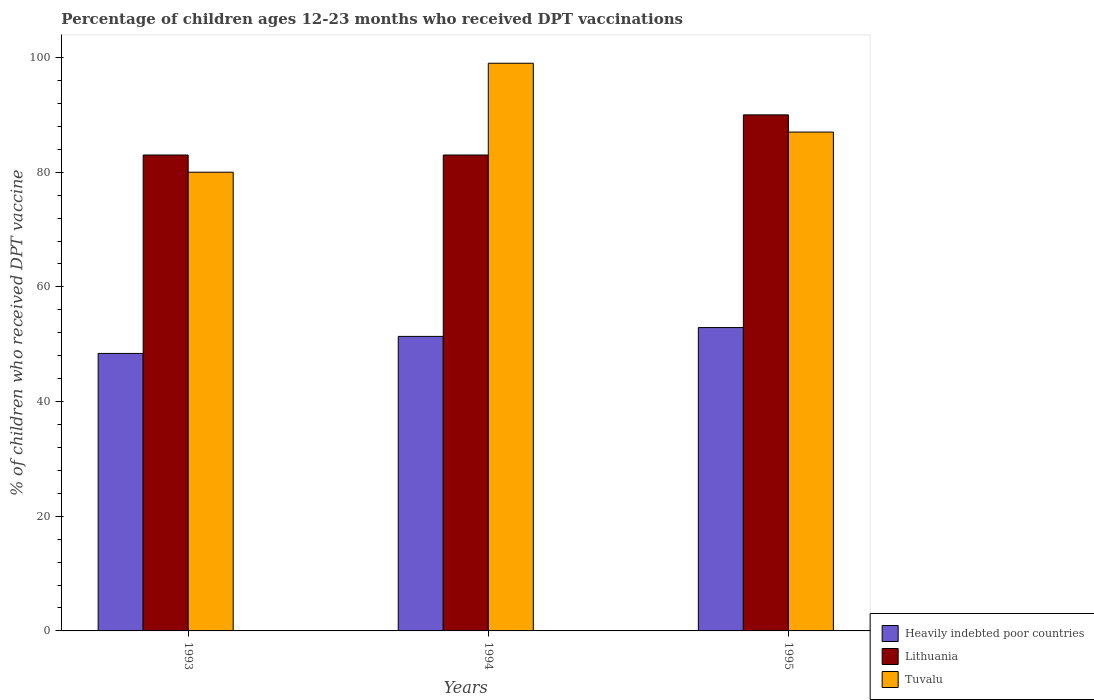How many groups of bars are there?
Ensure brevity in your answer.  3. Are the number of bars per tick equal to the number of legend labels?
Keep it short and to the point. Yes. How many bars are there on the 1st tick from the left?
Ensure brevity in your answer.  3. How many bars are there on the 1st tick from the right?
Offer a terse response. 3. What is the percentage of children who received DPT vaccination in Heavily indebted poor countries in 1995?
Provide a short and direct response. 52.91. Across all years, what is the minimum percentage of children who received DPT vaccination in Heavily indebted poor countries?
Your answer should be compact. 48.39. In which year was the percentage of children who received DPT vaccination in Heavily indebted poor countries maximum?
Your answer should be very brief. 1995. In which year was the percentage of children who received DPT vaccination in Heavily indebted poor countries minimum?
Make the answer very short. 1993. What is the total percentage of children who received DPT vaccination in Tuvalu in the graph?
Your response must be concise. 266. What is the difference between the percentage of children who received DPT vaccination in Tuvalu in 1993 and that in 1995?
Provide a succinct answer. -7. What is the difference between the percentage of children who received DPT vaccination in Lithuania in 1993 and the percentage of children who received DPT vaccination in Heavily indebted poor countries in 1994?
Your answer should be very brief. 31.64. What is the average percentage of children who received DPT vaccination in Tuvalu per year?
Your answer should be compact. 88.67. In the year 1994, what is the difference between the percentage of children who received DPT vaccination in Lithuania and percentage of children who received DPT vaccination in Tuvalu?
Provide a short and direct response. -16. In how many years, is the percentage of children who received DPT vaccination in Lithuania greater than 84 %?
Your response must be concise. 1. What is the ratio of the percentage of children who received DPT vaccination in Lithuania in 1994 to that in 1995?
Offer a terse response. 0.92. Is the percentage of children who received DPT vaccination in Heavily indebted poor countries in 1993 less than that in 1994?
Offer a terse response. Yes. Is the difference between the percentage of children who received DPT vaccination in Lithuania in 1993 and 1994 greater than the difference between the percentage of children who received DPT vaccination in Tuvalu in 1993 and 1994?
Offer a very short reply. Yes. What is the difference between the highest and the second highest percentage of children who received DPT vaccination in Heavily indebted poor countries?
Provide a succinct answer. 1.54. What is the difference between the highest and the lowest percentage of children who received DPT vaccination in Tuvalu?
Offer a terse response. 19. What does the 3rd bar from the left in 1993 represents?
Your answer should be compact. Tuvalu. What does the 1st bar from the right in 1995 represents?
Keep it short and to the point. Tuvalu. Is it the case that in every year, the sum of the percentage of children who received DPT vaccination in Tuvalu and percentage of children who received DPT vaccination in Heavily indebted poor countries is greater than the percentage of children who received DPT vaccination in Lithuania?
Keep it short and to the point. Yes. How many bars are there?
Give a very brief answer. 9. Are all the bars in the graph horizontal?
Provide a succinct answer. No. Where does the legend appear in the graph?
Provide a short and direct response. Bottom right. How many legend labels are there?
Make the answer very short. 3. What is the title of the graph?
Your answer should be very brief. Percentage of children ages 12-23 months who received DPT vaccinations. What is the label or title of the Y-axis?
Offer a very short reply. % of children who received DPT vaccine. What is the % of children who received DPT vaccine in Heavily indebted poor countries in 1993?
Offer a very short reply. 48.39. What is the % of children who received DPT vaccine of Tuvalu in 1993?
Give a very brief answer. 80. What is the % of children who received DPT vaccine in Heavily indebted poor countries in 1994?
Provide a succinct answer. 51.36. What is the % of children who received DPT vaccine in Lithuania in 1994?
Your response must be concise. 83. What is the % of children who received DPT vaccine of Heavily indebted poor countries in 1995?
Give a very brief answer. 52.91. What is the % of children who received DPT vaccine in Lithuania in 1995?
Your answer should be very brief. 90. Across all years, what is the maximum % of children who received DPT vaccine of Heavily indebted poor countries?
Make the answer very short. 52.91. Across all years, what is the minimum % of children who received DPT vaccine of Heavily indebted poor countries?
Your answer should be very brief. 48.39. Across all years, what is the minimum % of children who received DPT vaccine of Tuvalu?
Provide a short and direct response. 80. What is the total % of children who received DPT vaccine in Heavily indebted poor countries in the graph?
Give a very brief answer. 152.67. What is the total % of children who received DPT vaccine of Lithuania in the graph?
Your answer should be very brief. 256. What is the total % of children who received DPT vaccine of Tuvalu in the graph?
Your response must be concise. 266. What is the difference between the % of children who received DPT vaccine in Heavily indebted poor countries in 1993 and that in 1994?
Your answer should be compact. -2.97. What is the difference between the % of children who received DPT vaccine of Heavily indebted poor countries in 1993 and that in 1995?
Your answer should be compact. -4.51. What is the difference between the % of children who received DPT vaccine in Lithuania in 1993 and that in 1995?
Provide a short and direct response. -7. What is the difference between the % of children who received DPT vaccine of Tuvalu in 1993 and that in 1995?
Your response must be concise. -7. What is the difference between the % of children who received DPT vaccine of Heavily indebted poor countries in 1994 and that in 1995?
Provide a succinct answer. -1.54. What is the difference between the % of children who received DPT vaccine of Tuvalu in 1994 and that in 1995?
Give a very brief answer. 12. What is the difference between the % of children who received DPT vaccine in Heavily indebted poor countries in 1993 and the % of children who received DPT vaccine in Lithuania in 1994?
Make the answer very short. -34.61. What is the difference between the % of children who received DPT vaccine of Heavily indebted poor countries in 1993 and the % of children who received DPT vaccine of Tuvalu in 1994?
Keep it short and to the point. -50.61. What is the difference between the % of children who received DPT vaccine in Lithuania in 1993 and the % of children who received DPT vaccine in Tuvalu in 1994?
Keep it short and to the point. -16. What is the difference between the % of children who received DPT vaccine in Heavily indebted poor countries in 1993 and the % of children who received DPT vaccine in Lithuania in 1995?
Make the answer very short. -41.61. What is the difference between the % of children who received DPT vaccine of Heavily indebted poor countries in 1993 and the % of children who received DPT vaccine of Tuvalu in 1995?
Provide a short and direct response. -38.61. What is the difference between the % of children who received DPT vaccine in Heavily indebted poor countries in 1994 and the % of children who received DPT vaccine in Lithuania in 1995?
Your response must be concise. -38.64. What is the difference between the % of children who received DPT vaccine in Heavily indebted poor countries in 1994 and the % of children who received DPT vaccine in Tuvalu in 1995?
Give a very brief answer. -35.64. What is the difference between the % of children who received DPT vaccine of Lithuania in 1994 and the % of children who received DPT vaccine of Tuvalu in 1995?
Provide a short and direct response. -4. What is the average % of children who received DPT vaccine of Heavily indebted poor countries per year?
Make the answer very short. 50.89. What is the average % of children who received DPT vaccine in Lithuania per year?
Your answer should be very brief. 85.33. What is the average % of children who received DPT vaccine of Tuvalu per year?
Provide a succinct answer. 88.67. In the year 1993, what is the difference between the % of children who received DPT vaccine of Heavily indebted poor countries and % of children who received DPT vaccine of Lithuania?
Your answer should be compact. -34.61. In the year 1993, what is the difference between the % of children who received DPT vaccine of Heavily indebted poor countries and % of children who received DPT vaccine of Tuvalu?
Make the answer very short. -31.61. In the year 1994, what is the difference between the % of children who received DPT vaccine in Heavily indebted poor countries and % of children who received DPT vaccine in Lithuania?
Give a very brief answer. -31.64. In the year 1994, what is the difference between the % of children who received DPT vaccine of Heavily indebted poor countries and % of children who received DPT vaccine of Tuvalu?
Make the answer very short. -47.64. In the year 1995, what is the difference between the % of children who received DPT vaccine in Heavily indebted poor countries and % of children who received DPT vaccine in Lithuania?
Your response must be concise. -37.09. In the year 1995, what is the difference between the % of children who received DPT vaccine of Heavily indebted poor countries and % of children who received DPT vaccine of Tuvalu?
Give a very brief answer. -34.09. In the year 1995, what is the difference between the % of children who received DPT vaccine of Lithuania and % of children who received DPT vaccine of Tuvalu?
Provide a short and direct response. 3. What is the ratio of the % of children who received DPT vaccine of Heavily indebted poor countries in 1993 to that in 1994?
Ensure brevity in your answer.  0.94. What is the ratio of the % of children who received DPT vaccine in Tuvalu in 1993 to that in 1994?
Provide a short and direct response. 0.81. What is the ratio of the % of children who received DPT vaccine of Heavily indebted poor countries in 1993 to that in 1995?
Provide a succinct answer. 0.91. What is the ratio of the % of children who received DPT vaccine in Lithuania in 1993 to that in 1995?
Offer a very short reply. 0.92. What is the ratio of the % of children who received DPT vaccine in Tuvalu in 1993 to that in 1995?
Keep it short and to the point. 0.92. What is the ratio of the % of children who received DPT vaccine of Heavily indebted poor countries in 1994 to that in 1995?
Provide a succinct answer. 0.97. What is the ratio of the % of children who received DPT vaccine in Lithuania in 1994 to that in 1995?
Offer a terse response. 0.92. What is the ratio of the % of children who received DPT vaccine in Tuvalu in 1994 to that in 1995?
Offer a terse response. 1.14. What is the difference between the highest and the second highest % of children who received DPT vaccine of Heavily indebted poor countries?
Give a very brief answer. 1.54. What is the difference between the highest and the second highest % of children who received DPT vaccine of Lithuania?
Your answer should be compact. 7. What is the difference between the highest and the second highest % of children who received DPT vaccine in Tuvalu?
Provide a short and direct response. 12. What is the difference between the highest and the lowest % of children who received DPT vaccine in Heavily indebted poor countries?
Provide a succinct answer. 4.51. 